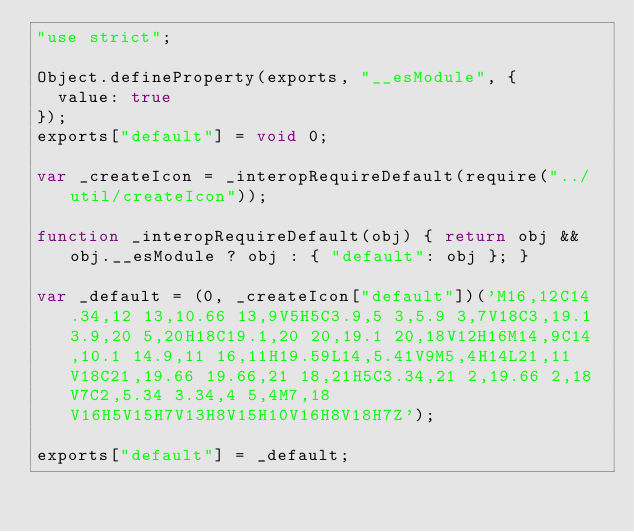Convert code to text. <code><loc_0><loc_0><loc_500><loc_500><_JavaScript_>"use strict";

Object.defineProperty(exports, "__esModule", {
  value: true
});
exports["default"] = void 0;

var _createIcon = _interopRequireDefault(require("../util/createIcon"));

function _interopRequireDefault(obj) { return obj && obj.__esModule ? obj : { "default": obj }; }

var _default = (0, _createIcon["default"])('M16,12C14.34,12 13,10.66 13,9V5H5C3.9,5 3,5.9 3,7V18C3,19.1 3.9,20 5,20H18C19.1,20 20,19.1 20,18V12H16M14,9C14,10.1 14.9,11 16,11H19.59L14,5.41V9M5,4H14L21,11V18C21,19.66 19.66,21 18,21H5C3.34,21 2,19.66 2,18V7C2,5.34 3.34,4 5,4M7,18V16H5V15H7V13H8V15H10V16H8V18H7Z');

exports["default"] = _default;</code> 